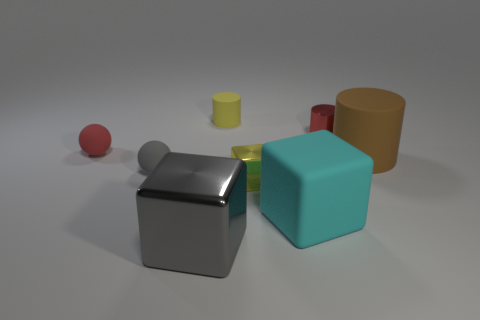Are there any matte spheres that have the same color as the rubber block?
Provide a short and direct response. No. Do the matte sphere that is in front of the large brown object and the matte cylinder that is on the right side of the tiny yellow cylinder have the same color?
Offer a very short reply. No. What is the material of the small yellow object that is behind the metallic cylinder?
Your response must be concise. Rubber. There is another block that is made of the same material as the tiny yellow block; what is its color?
Give a very brief answer. Gray. How many other rubber balls are the same size as the gray sphere?
Your answer should be very brief. 1. Do the brown matte cylinder that is behind the rubber block and the large cyan matte object have the same size?
Your answer should be very brief. Yes. The rubber object that is right of the gray rubber sphere and in front of the brown object has what shape?
Your response must be concise. Cube. Are there any brown cylinders behind the metal cylinder?
Provide a short and direct response. No. Is there any other thing that has the same shape as the cyan matte object?
Offer a terse response. Yes. Is the gray shiny thing the same shape as the big brown rubber object?
Keep it short and to the point. No. 